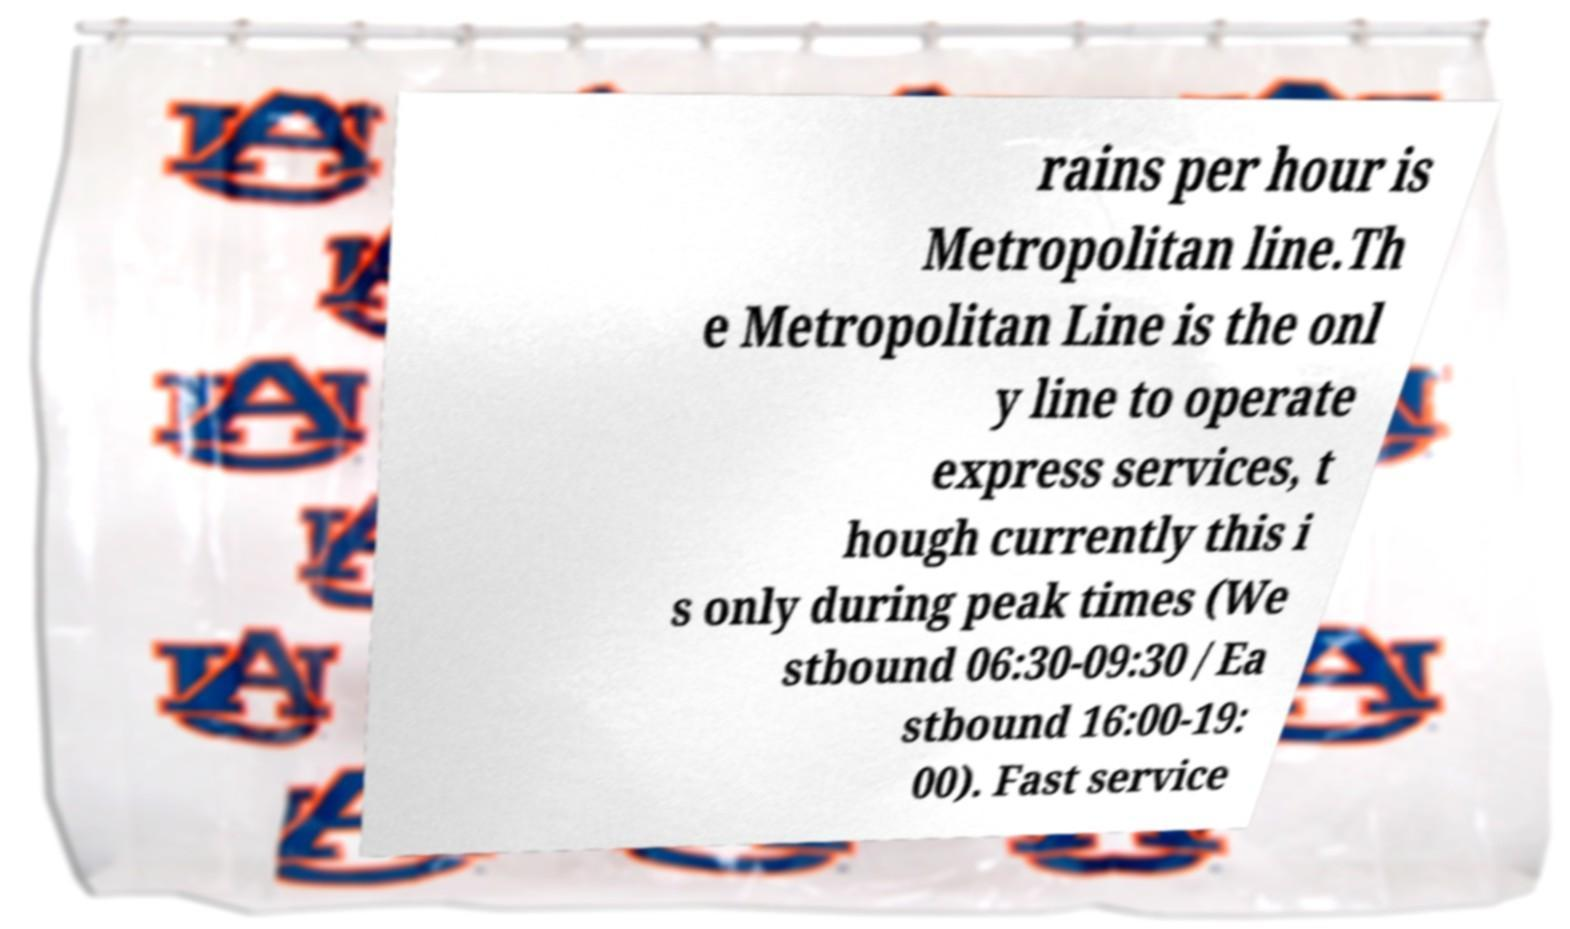There's text embedded in this image that I need extracted. Can you transcribe it verbatim? rains per hour is Metropolitan line.Th e Metropolitan Line is the onl y line to operate express services, t hough currently this i s only during peak times (We stbound 06:30-09:30 / Ea stbound 16:00-19: 00). Fast service 